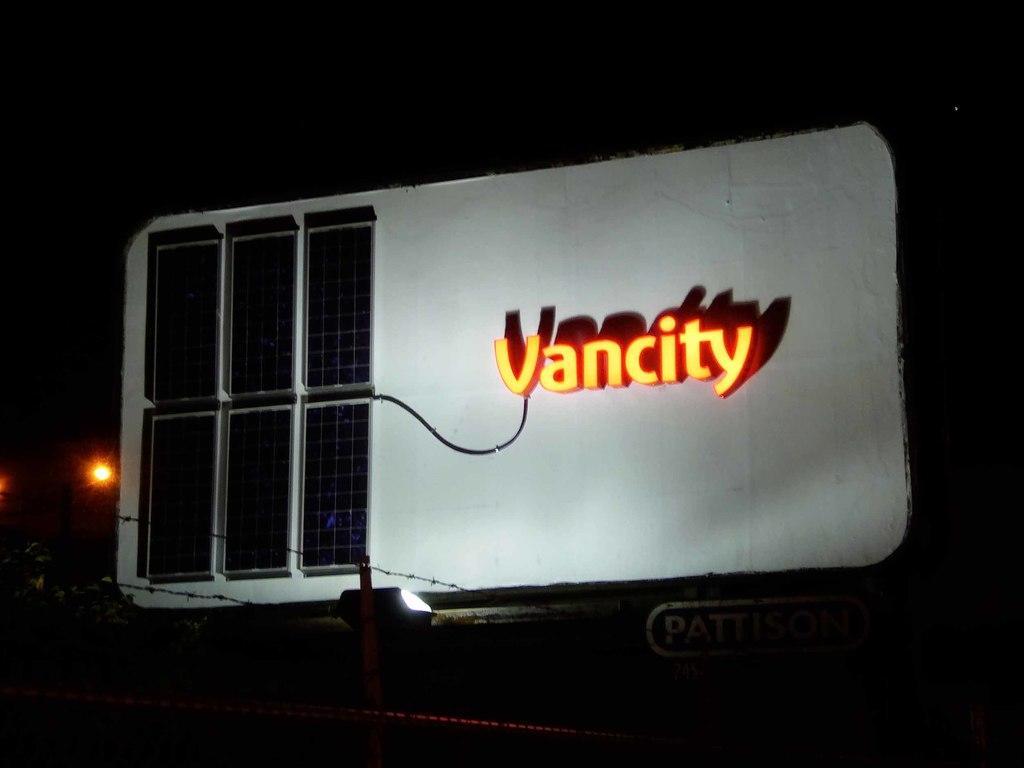How would you summarize this image in a sentence or two? It's a name, there is an orange color light in it. 